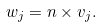<formula> <loc_0><loc_0><loc_500><loc_500>w _ { j } = n \times v _ { j } .</formula> 